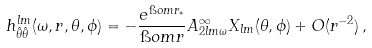<formula> <loc_0><loc_0><loc_500><loc_500>h _ { \hat { \theta } \hat { \theta } } ^ { l m } ( \omega , r , \theta , \phi ) = - \frac { e ^ { \i o m r _ { * } } } { \i o m r } A ^ { \infty } _ { 2 l m \omega } X _ { l m } ( \theta , \phi ) + O ( r ^ { - 2 } ) \, ,</formula> 